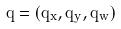Convert formula to latex. <formula><loc_0><loc_0><loc_500><loc_500>q = ( q _ { x } , q _ { y } , q _ { w } )</formula> 